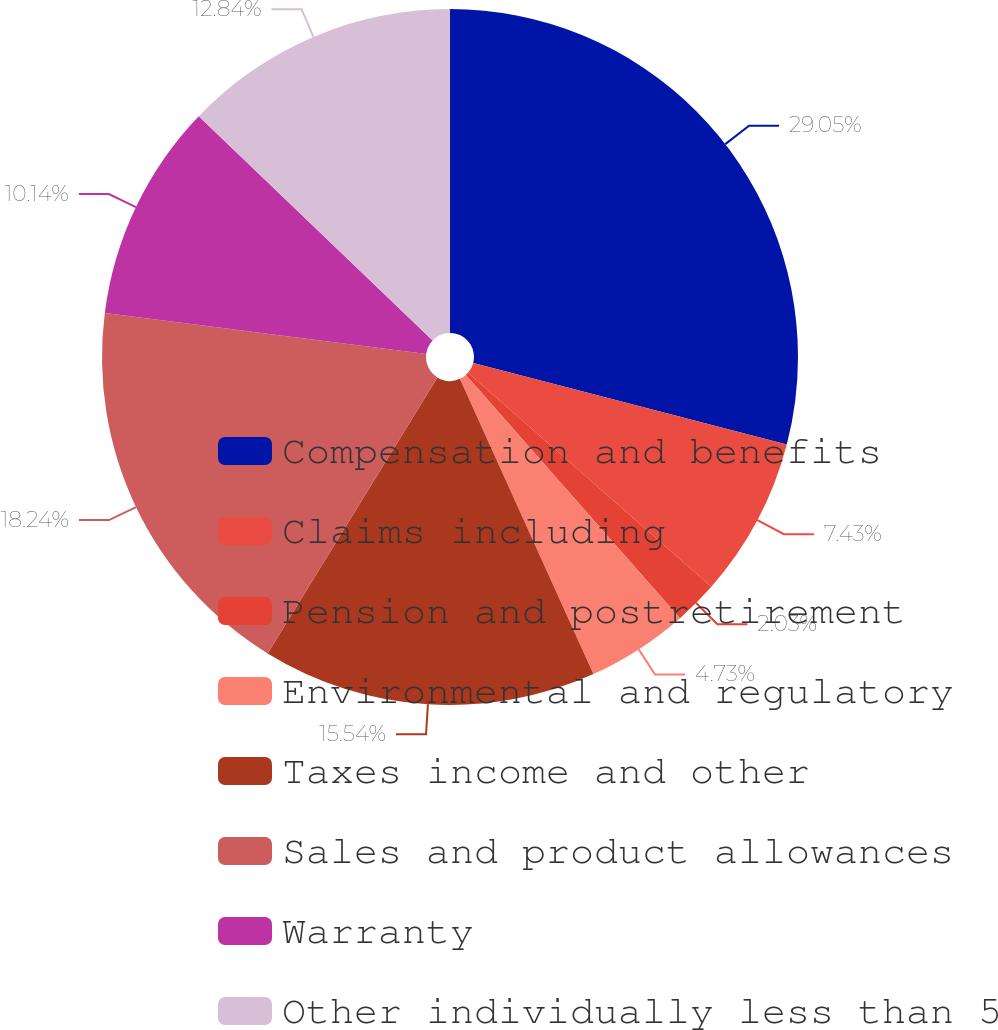Convert chart to OTSL. <chart><loc_0><loc_0><loc_500><loc_500><pie_chart><fcel>Compensation and benefits<fcel>Claims including<fcel>Pension and postretirement<fcel>Environmental and regulatory<fcel>Taxes income and other<fcel>Sales and product allowances<fcel>Warranty<fcel>Other individually less than 5<nl><fcel>29.05%<fcel>7.43%<fcel>2.03%<fcel>4.73%<fcel>15.54%<fcel>18.24%<fcel>10.14%<fcel>12.84%<nl></chart> 